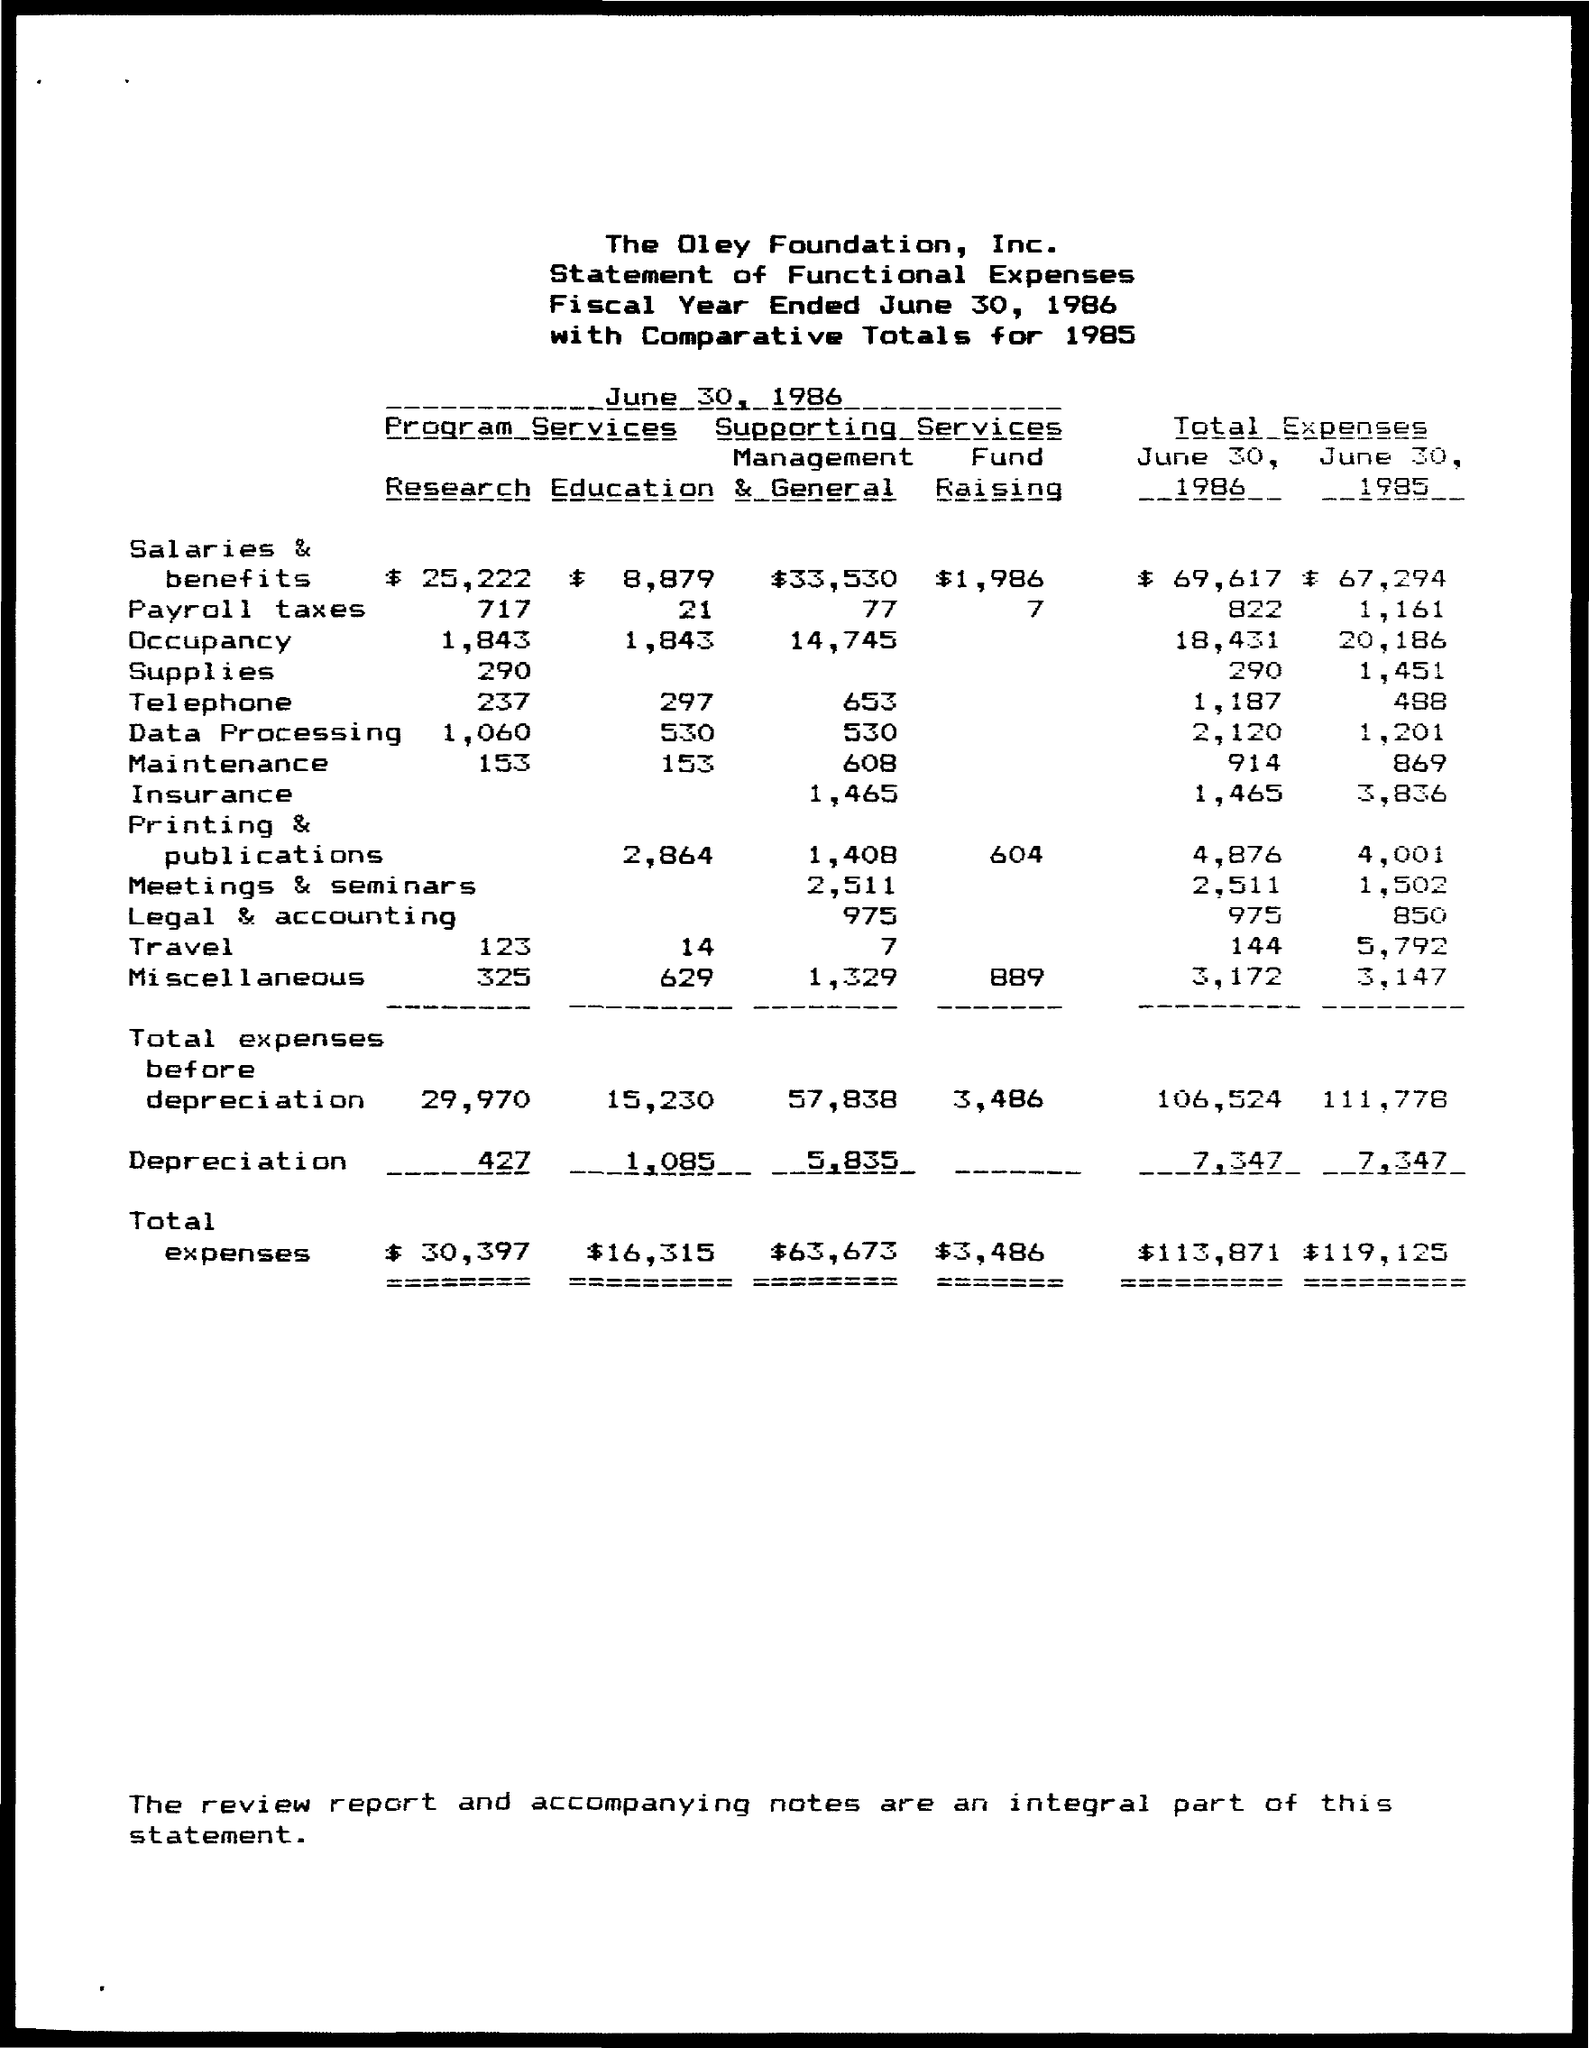What are the total expenses for salaries and benefits for June 30, 1986?
Your answer should be compact. $69,617. What are the total expenses for salaries and benefits for June 30, 1985?
Offer a terse response. $67,294. What are the total expenses for Payroll Taxes for June 30, 1986?
Give a very brief answer. 822. What are the total expenses for Payroll Taxes for June 30, 1985?
Make the answer very short. 1,161. What are the total expenses for Occupancy for June 30, 1986?
Your answer should be very brief. 18,431. What are the total expenses for Occupancy for June 30, 1985?
Provide a succinct answer. 20,186. What are the total expenses for Supplies for June 30, 1986?
Offer a very short reply. 290. What are the total expenses for Supplies for June 30, 1985?
Give a very brief answer. 1,451. What are the total expenses for Telephone for June 30, 1986?
Offer a very short reply. 1,187. What are the total expenses for Telephone for June 30, 1985?
Ensure brevity in your answer.  488. 